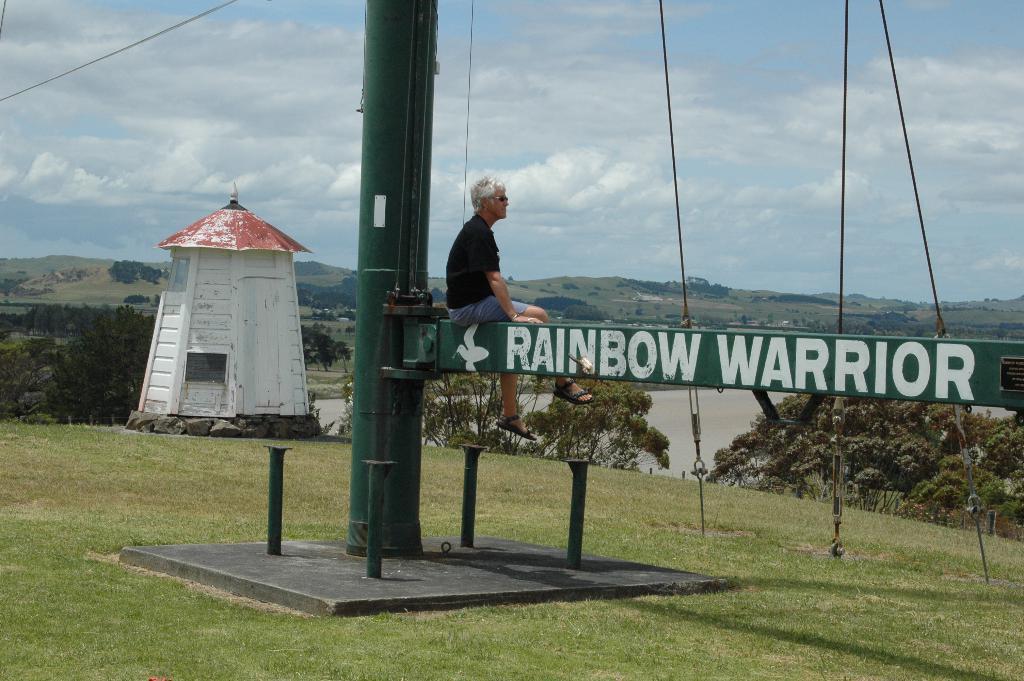Describe this image in one or two sentences. In this picture I can see the grass in front and on the grass I see a pole and I see something is written on it and I see a man who is sitting on it and I see the wires and in the middle of this picture I see the trees and a tower on the left side of this image and in the background I see the sky. 